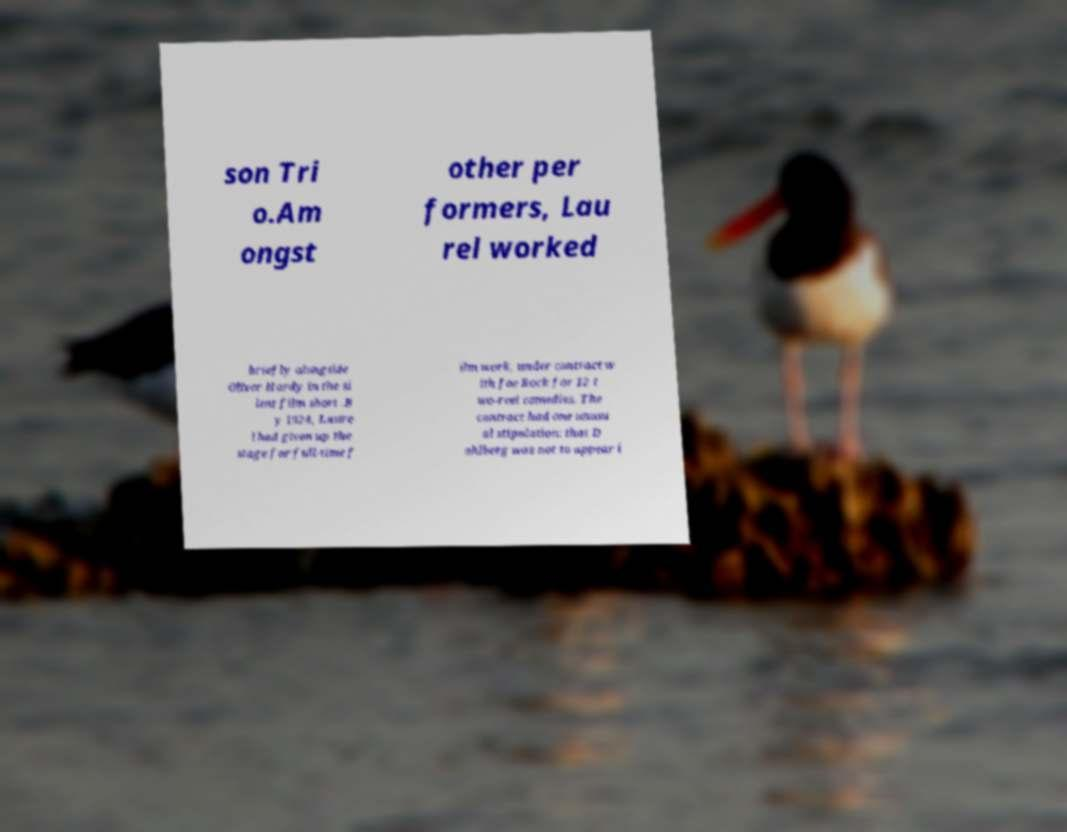Could you extract and type out the text from this image? son Tri o.Am ongst other per formers, Lau rel worked briefly alongside Oliver Hardy in the si lent film short .B y 1924, Laure l had given up the stage for full-time f ilm work, under contract w ith Joe Rock for 12 t wo-reel comedies. The contract had one unusu al stipulation: that D ahlberg was not to appear i 